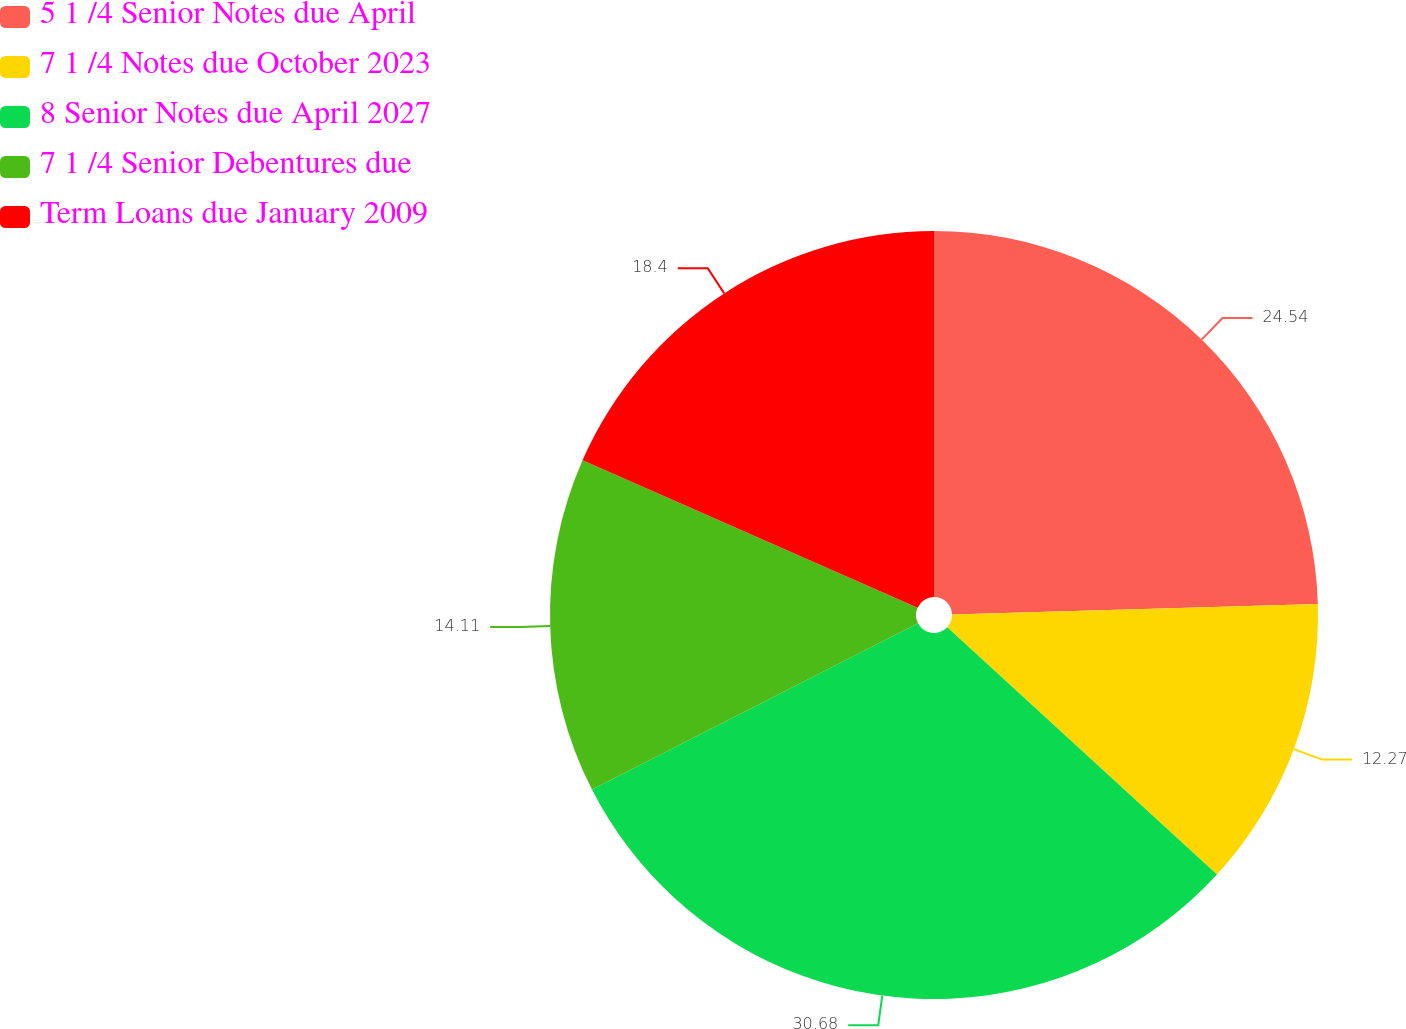Convert chart. <chart><loc_0><loc_0><loc_500><loc_500><pie_chart><fcel>5 1 /4 Senior Notes due April<fcel>7 1 /4 Notes due October 2023<fcel>8 Senior Notes due April 2027<fcel>7 1 /4 Senior Debentures due<fcel>Term Loans due January 2009<nl><fcel>24.54%<fcel>12.27%<fcel>30.67%<fcel>14.11%<fcel>18.4%<nl></chart> 